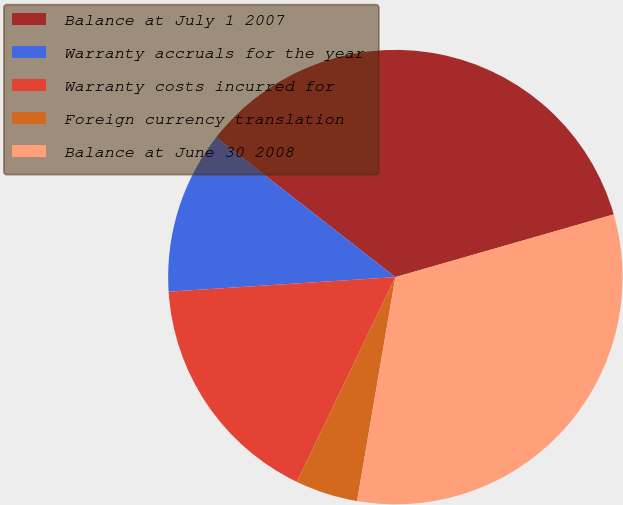Convert chart to OTSL. <chart><loc_0><loc_0><loc_500><loc_500><pie_chart><fcel>Balance at July 1 2007<fcel>Warranty accruals for the year<fcel>Warranty costs incurred for<fcel>Foreign currency translation<fcel>Balance at June 30 2008<nl><fcel>35.0%<fcel>11.57%<fcel>16.84%<fcel>4.44%<fcel>32.14%<nl></chart> 